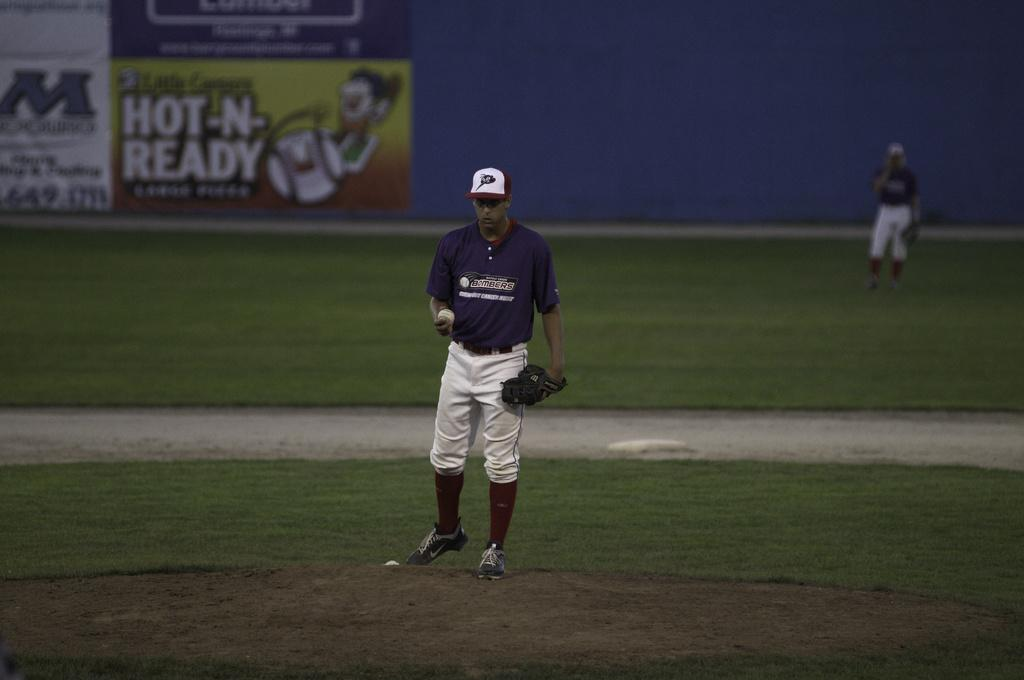<image>
Give a short and clear explanation of the subsequent image. Pitcher on the mound wearing a Bombers shirt that is getting ready to throw a baseball. 